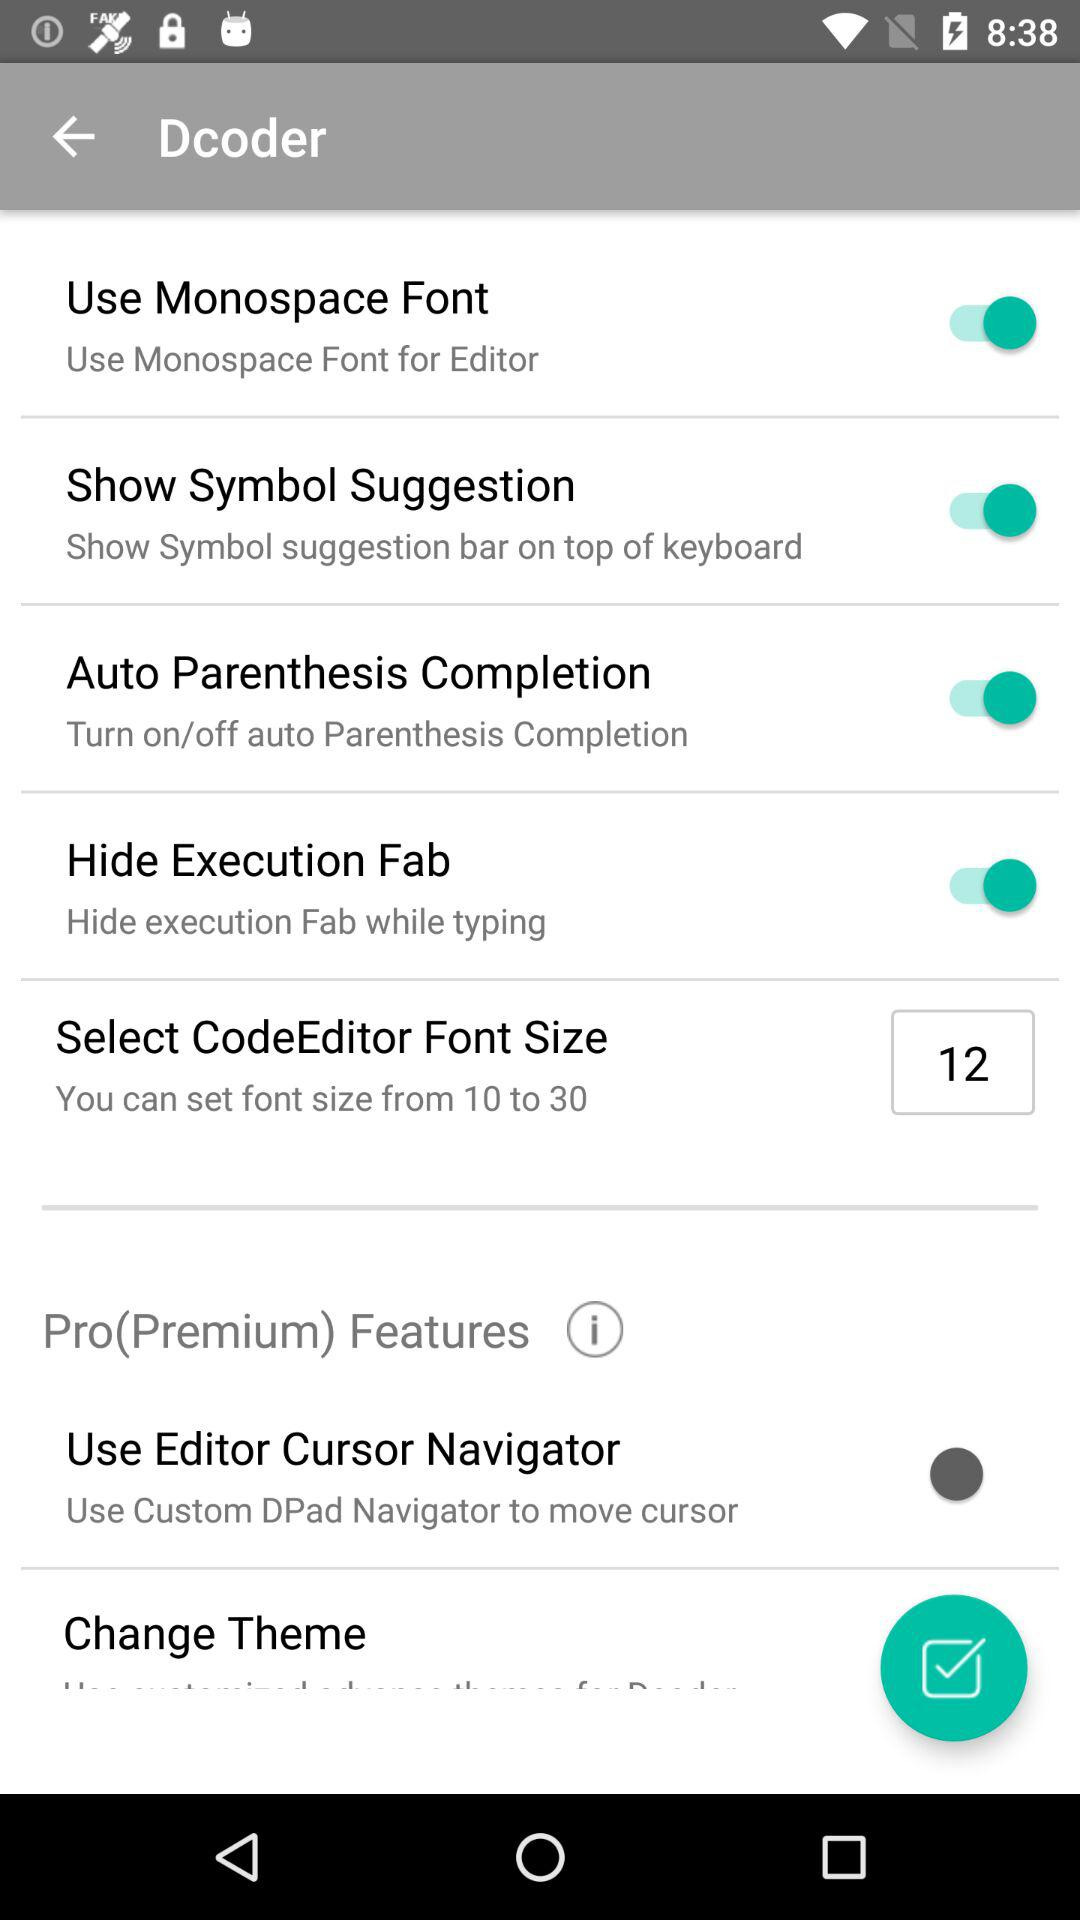How many font sizes can be selected?
Answer the question using a single word or phrase. 10 to 30 